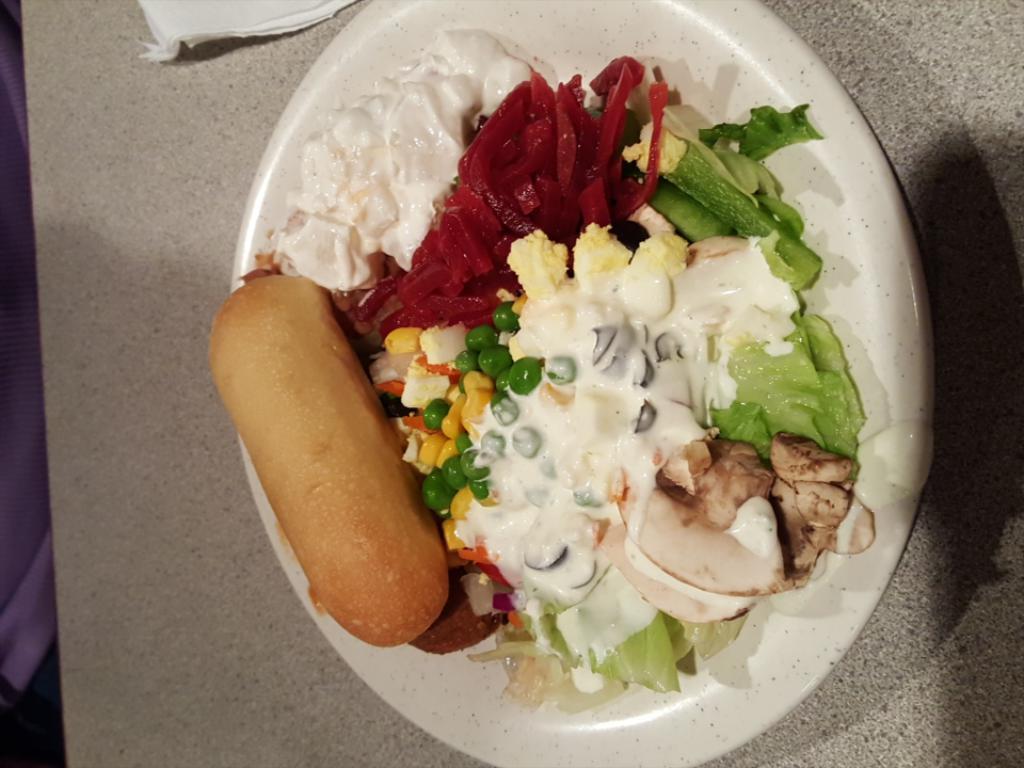Please provide a concise description of this image. In this image there is so much of served on bowl and kept on table, beside that there is a tissue. 